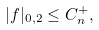<formula> <loc_0><loc_0><loc_500><loc_500>| f | _ { 0 , 2 } \leq C ^ { + } _ { n } ,</formula> 